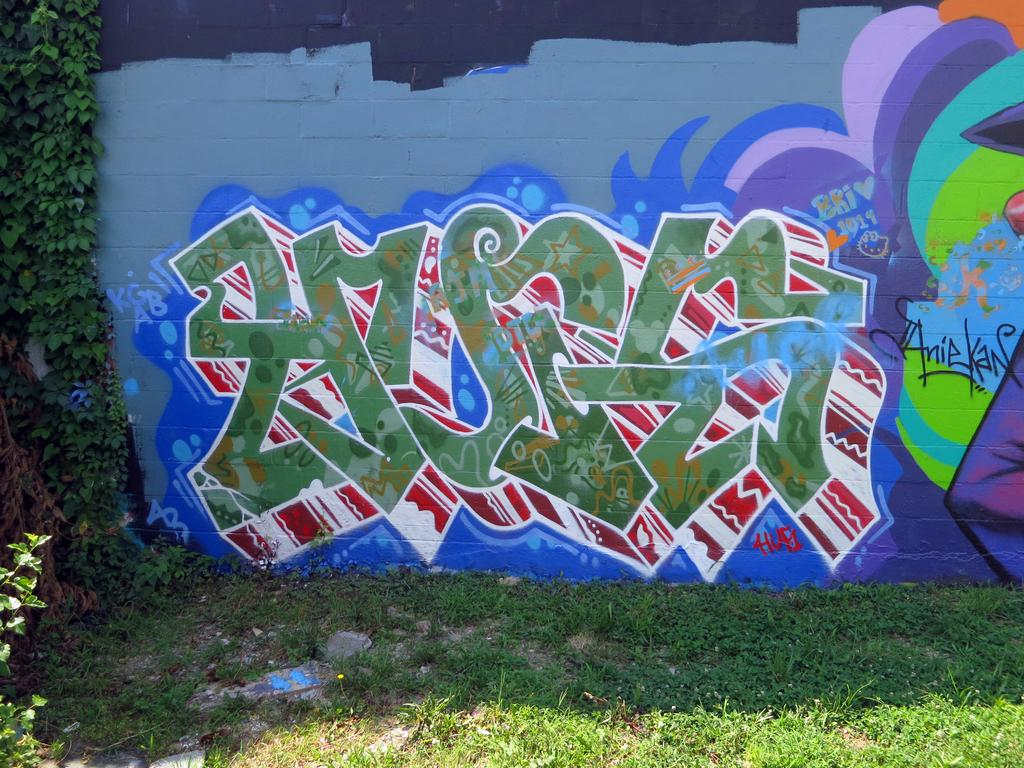What is depicted on the wall in the image? There is graffiti on a wall in the image. What can be seen on the left side of the image? There are plants on the left side of the image. What type of vegetation is visible at the bottom of the image? There is grass visible at the bottom of the image. What type of ground cover is present at the bottom of the image? Small stones are present on the ground at the bottom of the image. What emotion does the tree in the image convey? There is no tree present in the image, so it cannot convey any emotion. 